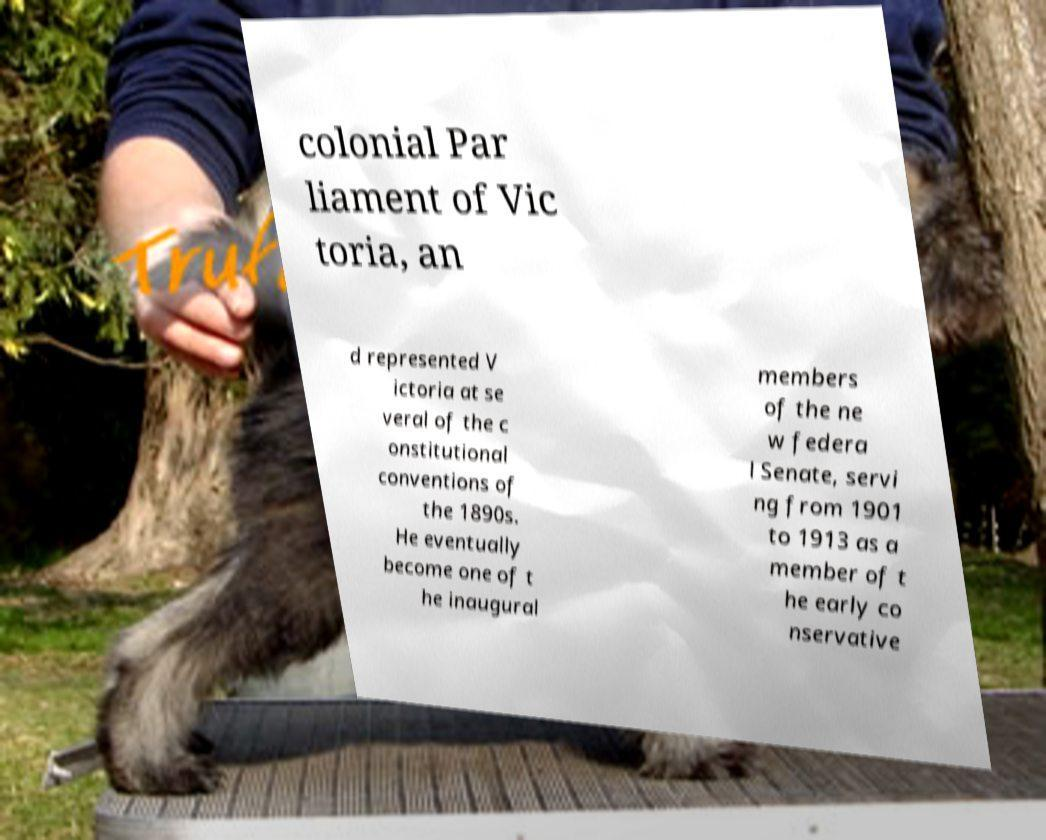What messages or text are displayed in this image? I need them in a readable, typed format. colonial Par liament of Vic toria, an d represented V ictoria at se veral of the c onstitutional conventions of the 1890s. He eventually become one of t he inaugural members of the ne w federa l Senate, servi ng from 1901 to 1913 as a member of t he early co nservative 